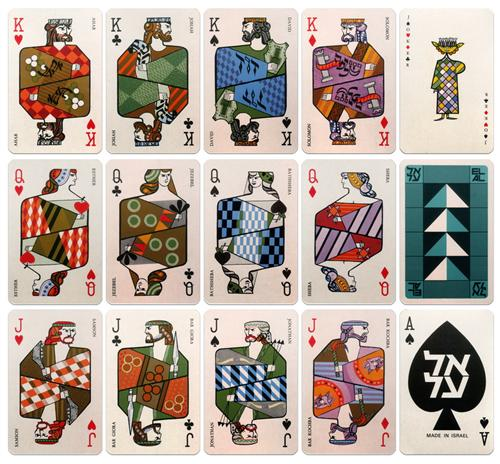What might be the symbolic meanings attached to the unique designs on each of the face cards? The unique designs on each face card could symbolize various themes or attributes associated with their ranks. For instance, kings being adorned with robust and commanding geometric shapes might represent power and authority, while queens, illustrated with smoother lines and soothing color palettes, could symbolize grace and diplomacy. Jacks often depicted with more playful and varied patterns might represent youth and cunning. Each design, through its use of color and form, subtly communicates the card’s traditional role in the game while offering a modern artistic twist that could invoke deeper reflections on these roles. 